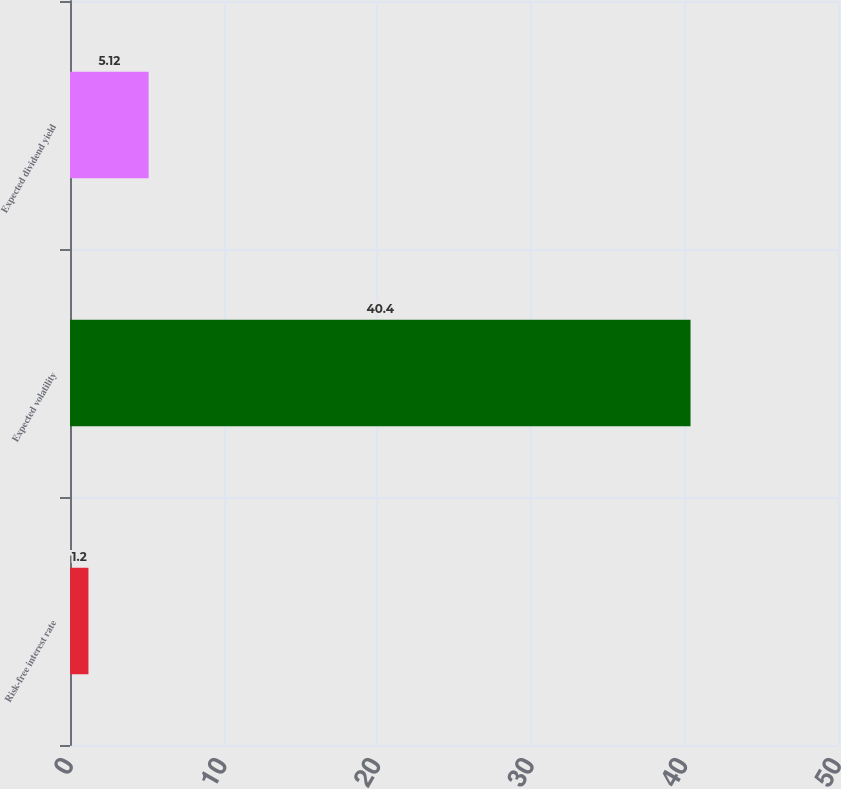Convert chart to OTSL. <chart><loc_0><loc_0><loc_500><loc_500><bar_chart><fcel>Risk-free interest rate<fcel>Expected volatility<fcel>Expected dividend yield<nl><fcel>1.2<fcel>40.4<fcel>5.12<nl></chart> 